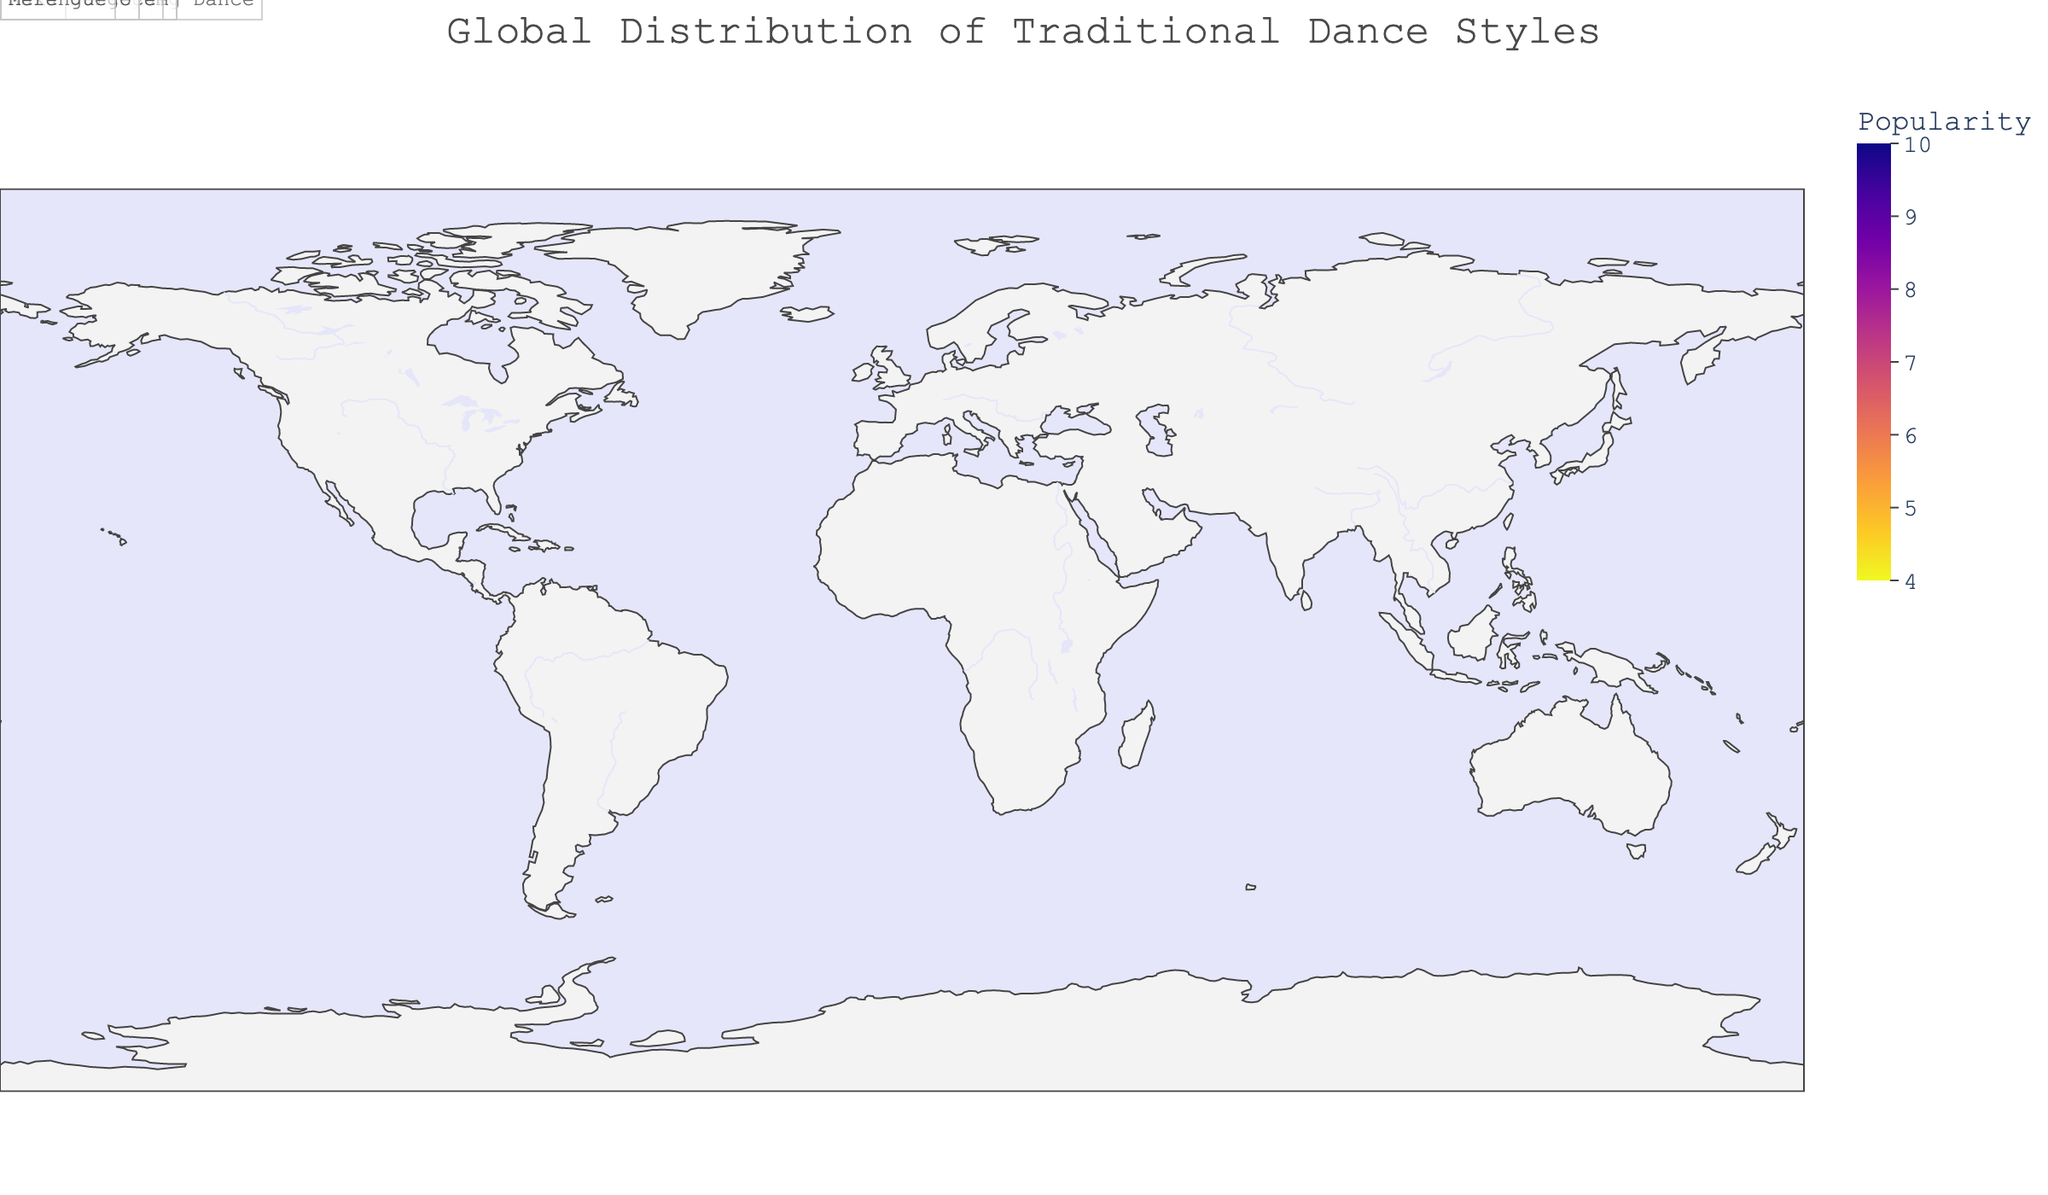What's the most popular traditional dance style in South America? The popularity score for Samba in South America is given as 9. Samba in South America scores 9 for popularity, making it the most popular traditional dance style in this continent.
Answer: Samba Which two regions both have dance styles with a popularity score of 8? The regions with dance styles having a popularity score of 8 are Western Europe and the Caribbean. Flamenco in Western Europe and Merengue in the Caribbean both score an 8.
Answer: Western Europe and Caribbean What is the least popular dance style in the dataset and which region does it belong to? The dataset shows that Maasai Jumping Dance in East Africa and Kara Jorgo in Central Asia both have the lowest popularity score of 5.
Answer: Maasai Jumping Dance and Kara Jorgo How many regions have dance styles with a popularity score of 7 or higher? By adding the regions with scores of 7, 8, and 9, we find:
North America (7), South America (9), Western Europe (8), North Africa (7), Middle East (8), South Asia (9), Southeast Asia (7), East Asia (8), Oceania (7), Caribbean (8). That's a total of 10 regions.
Answer: 10 Which region has a dance style equivalent in popularity to Gumboot Dance? Both Gumboot Dance in Southern Africa and Adowa in West Africa have a popularity score of 6.
Answer: West Africa What is the average popularity score of the dance styles in Africa? Four African regions are listed: North Africa (7), West Africa (6), East Africa (5), and Southern Africa (6). The average is calculated as (7 + 6 + 5 + 6) / 4 = 6.
Answer: 6 If you were to visit a region with a traditional dance style popularity score of at least 9, which regions would that be? The regions with a dance style having a popularity score of at least 9 are South America with Samba and South Asia with Bharatanatyam.
Answer: South America and South Asia What is the total number of traditional dance styles with a popularity score of 8? The regions with dance styles scoring 8 include Western Europe (Flamenco), Middle East (Dabke), East Asia (Lion Dance), and Caribbean (Merengue), totaling 4 traditional dance styles.
Answer: 4 Among the regions listed, which one has a dance style called "Dabke" and what is its popularity score? The region associated with "Dabke" is the Middle East, having a popularity score of 8.
Answer: Middle East and 8 